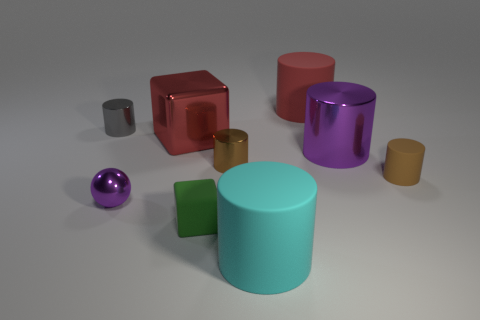Is the number of red metallic cubes greater than the number of large purple balls?
Ensure brevity in your answer.  Yes. What number of small cylinders are the same color as the tiny sphere?
Provide a short and direct response. 0. There is a large metallic object that is the same shape as the red matte object; what color is it?
Make the answer very short. Purple. What material is the cylinder that is both in front of the tiny brown shiny cylinder and behind the cyan cylinder?
Provide a short and direct response. Rubber. Do the large cylinder that is in front of the tiny rubber cylinder and the big red thing that is behind the large red metal thing have the same material?
Offer a very short reply. Yes. How big is the red cylinder?
Make the answer very short. Large. The purple object that is the same shape as the cyan object is what size?
Offer a very short reply. Large. How many purple shiny objects are on the right side of the big cyan cylinder?
Your response must be concise. 1. The rubber object that is left of the big cylinder left of the red rubber thing is what color?
Keep it short and to the point. Green. Is there any other thing that is the same shape as the gray object?
Offer a very short reply. Yes. 